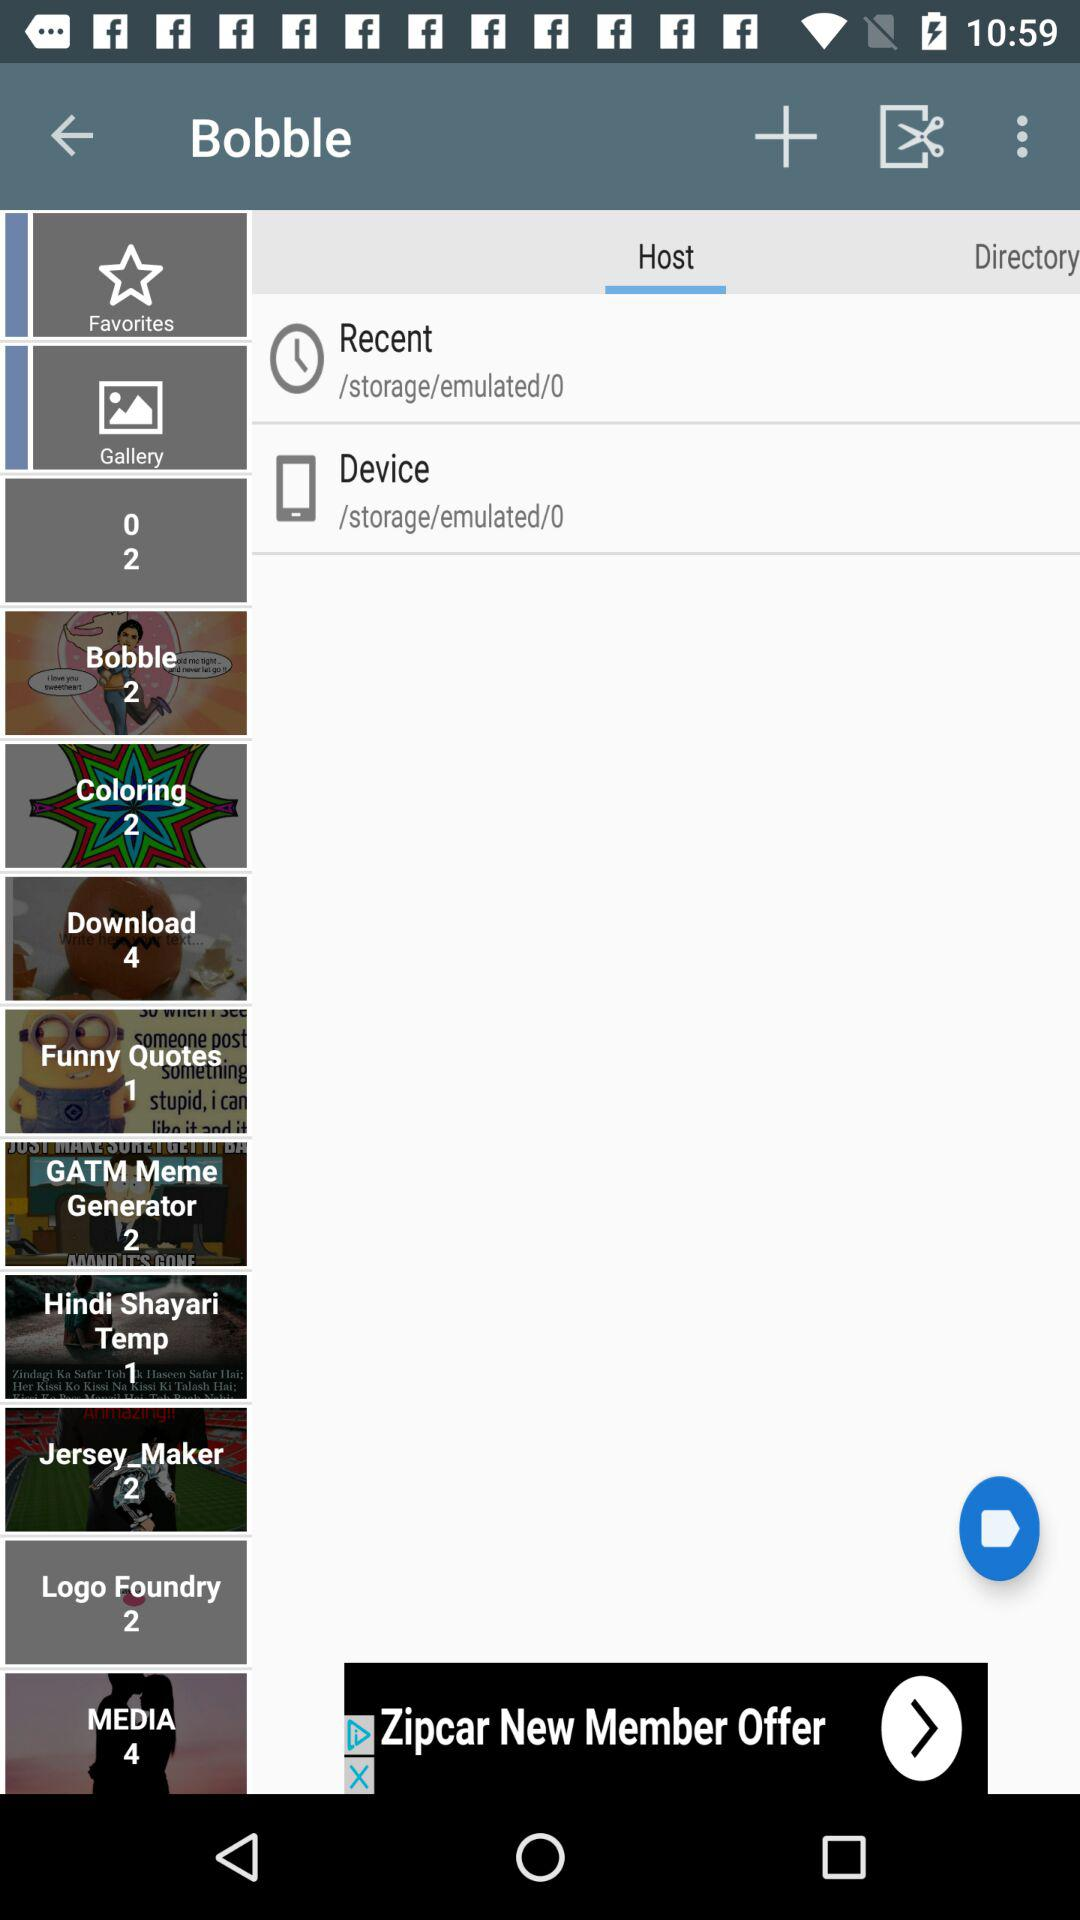What is the number in the "Download"? The number is 4. 